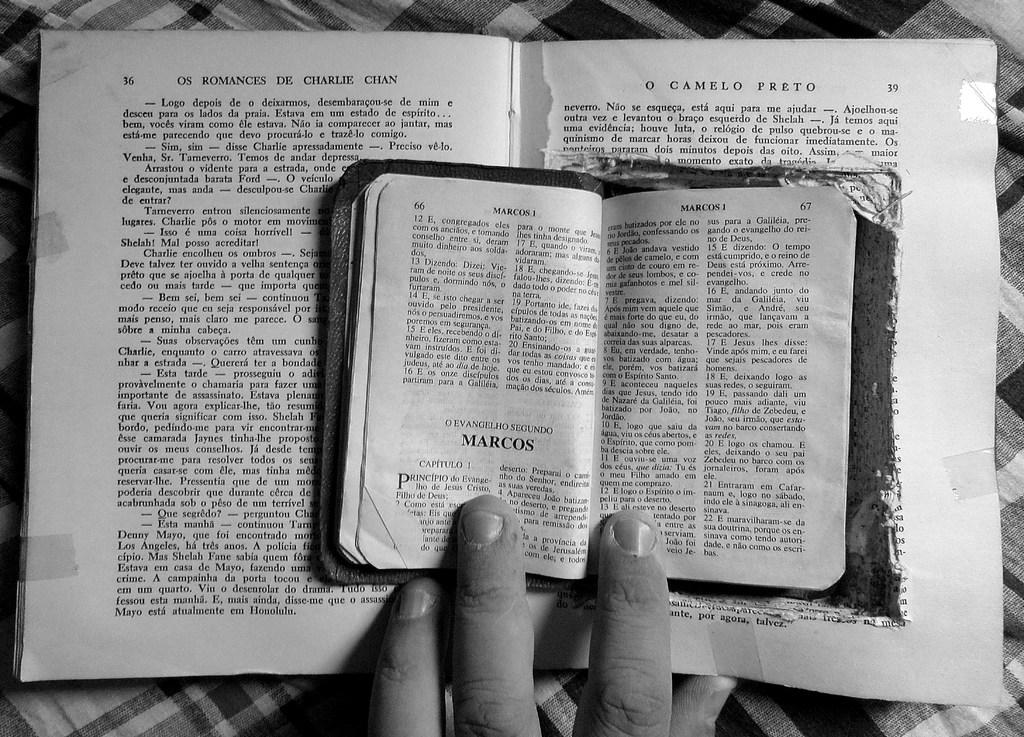What chapter is showing in the bible ?
Provide a succinct answer. Marcos. What is the name in bold print on the smaller book?
Ensure brevity in your answer.  Marcos. 